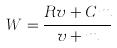<formula> <loc_0><loc_0><loc_500><loc_500>W = \frac { R v + C m } { v + m }</formula> 